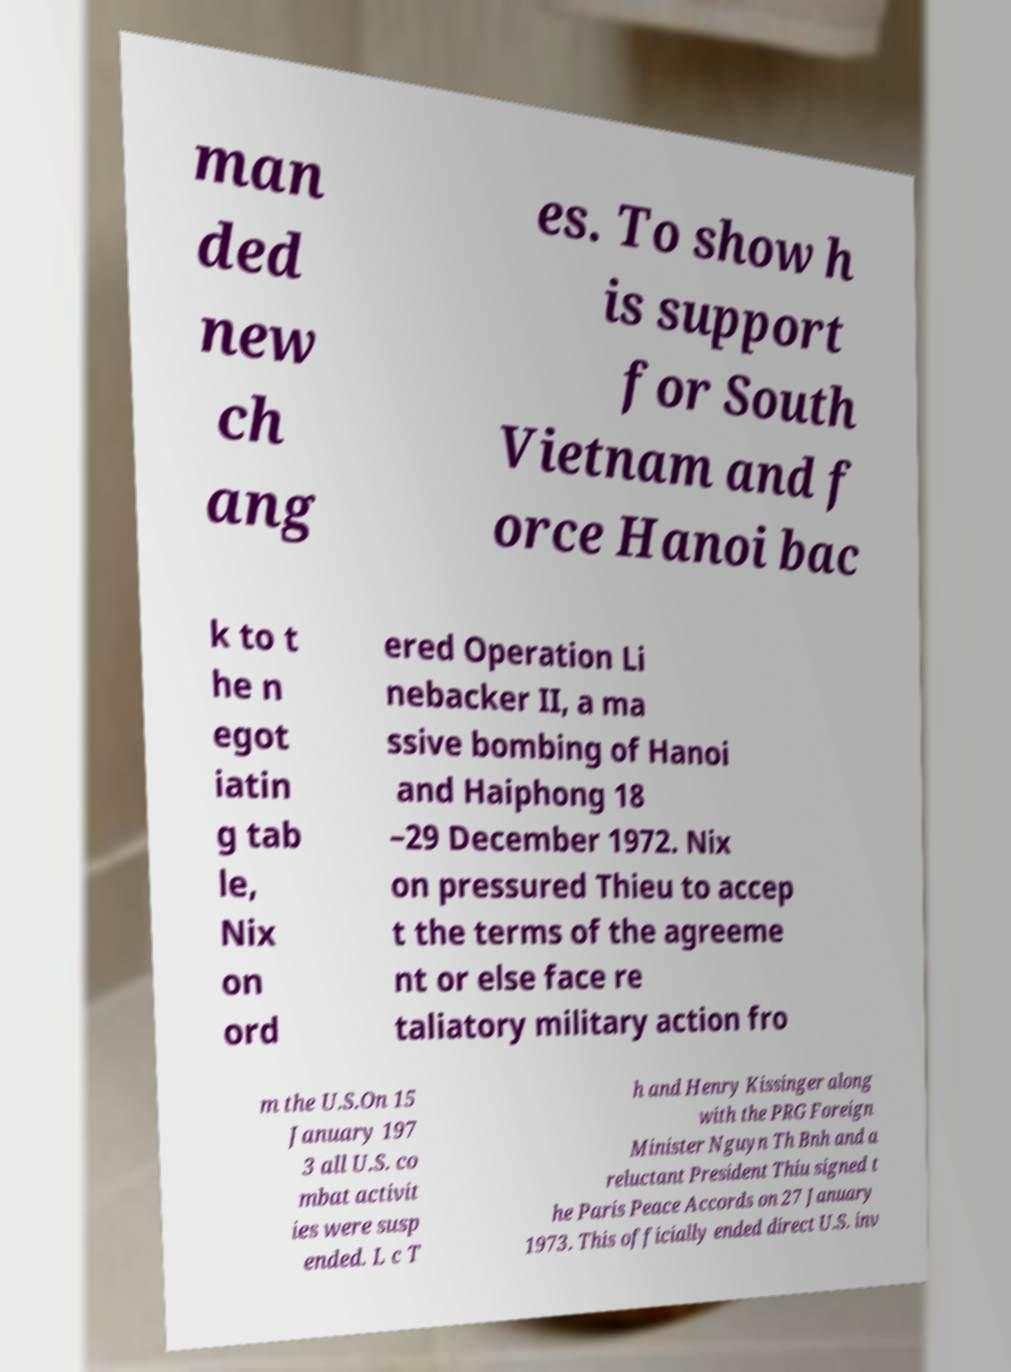There's text embedded in this image that I need extracted. Can you transcribe it verbatim? man ded new ch ang es. To show h is support for South Vietnam and f orce Hanoi bac k to t he n egot iatin g tab le, Nix on ord ered Operation Li nebacker II, a ma ssive bombing of Hanoi and Haiphong 18 –29 December 1972. Nix on pressured Thieu to accep t the terms of the agreeme nt or else face re taliatory military action fro m the U.S.On 15 January 197 3 all U.S. co mbat activit ies were susp ended. L c T h and Henry Kissinger along with the PRG Foreign Minister Nguyn Th Bnh and a reluctant President Thiu signed t he Paris Peace Accords on 27 January 1973. This officially ended direct U.S. inv 